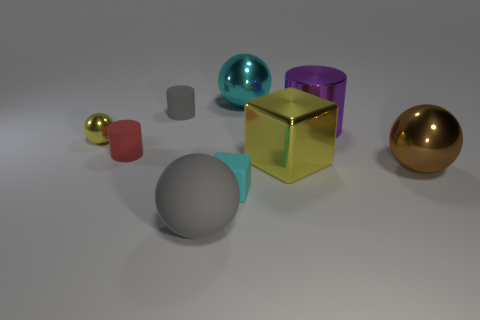Add 1 big brown metal objects. How many objects exist? 10 Subtract all cubes. How many objects are left? 7 Add 6 large shiny cylinders. How many large shiny cylinders are left? 7 Add 5 red cylinders. How many red cylinders exist? 6 Subtract 1 gray cylinders. How many objects are left? 8 Subtract all gray metal blocks. Subtract all gray rubber spheres. How many objects are left? 8 